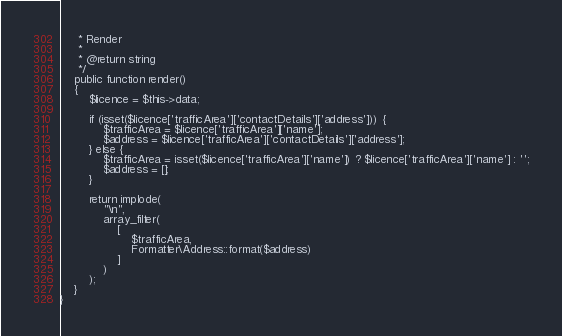<code> <loc_0><loc_0><loc_500><loc_500><_PHP_>     * Render
     *
     * @return string
     */
    public function render()
    {
        $licence = $this->data;

        if (isset($licence['trafficArea']['contactDetails']['address'])) {
            $trafficArea = $licence['trafficArea']['name'];
            $address = $licence['trafficArea']['contactDetails']['address'];
        } else {
            $trafficArea = isset($licence['trafficArea']['name']) ? $licence['trafficArea']['name'] : '';
            $address = [];
        }

        return implode(
            "\n",
            array_filter(
                [
                    $trafficArea,
                    Formatter\Address::format($address)
                ]
            )
        );
    }
}
</code> 